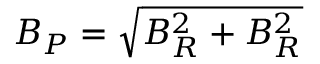<formula> <loc_0><loc_0><loc_500><loc_500>B _ { P } = \sqrt { B _ { R } ^ { 2 } + B _ { R } ^ { 2 } }</formula> 